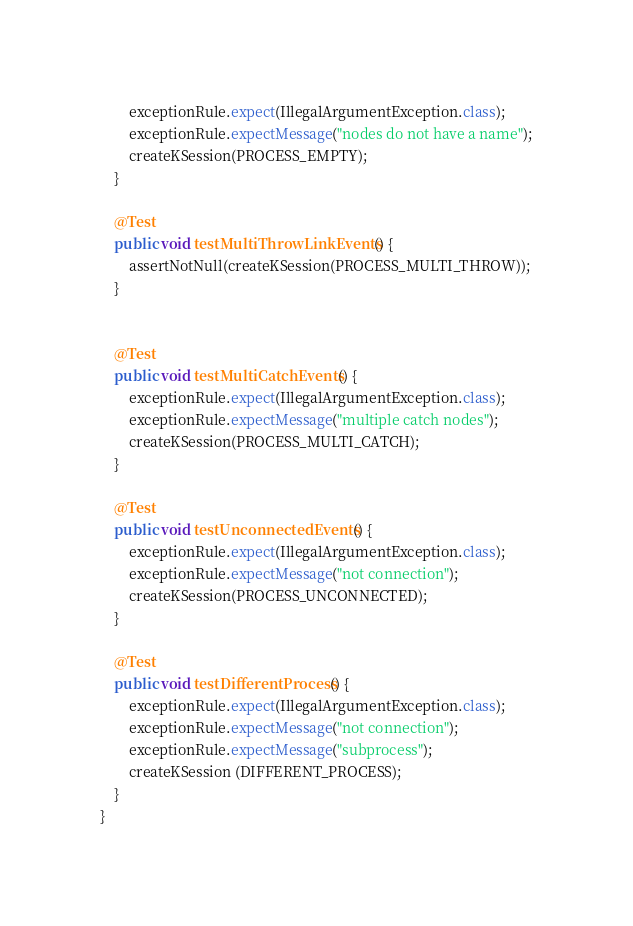Convert code to text. <code><loc_0><loc_0><loc_500><loc_500><_Java_>        exceptionRule.expect(IllegalArgumentException.class);
        exceptionRule.expectMessage("nodes do not have a name");
        createKSession(PROCESS_EMPTY);
    }
    
    @Test
    public void testMultiThrowLinkEvents() {
        assertNotNull(createKSession(PROCESS_MULTI_THROW));
    }
    

    @Test
    public void testMultiCatchEvents() {
        exceptionRule.expect(IllegalArgumentException.class);
        exceptionRule.expectMessage("multiple catch nodes");
        createKSession(PROCESS_MULTI_CATCH);
    }
    
    @Test
    public void testUnconnectedEvents() {
        exceptionRule.expect(IllegalArgumentException.class);
        exceptionRule.expectMessage("not connection");
        createKSession(PROCESS_UNCONNECTED);
    }
    
    @Test
    public void testDifferentProcess() {
        exceptionRule.expect(IllegalArgumentException.class);
        exceptionRule.expectMessage("not connection");
        exceptionRule.expectMessage("subprocess");
        createKSession (DIFFERENT_PROCESS);
    }
}
</code> 